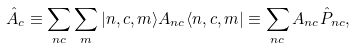Convert formula to latex. <formula><loc_0><loc_0><loc_500><loc_500>\hat { A } _ { c } \equiv \sum _ { n c } \sum _ { m } | n , c , m \rangle A _ { n c } \langle n , c , m | \equiv \sum _ { n c } A _ { n c } \hat { P } _ { n c } ,</formula> 